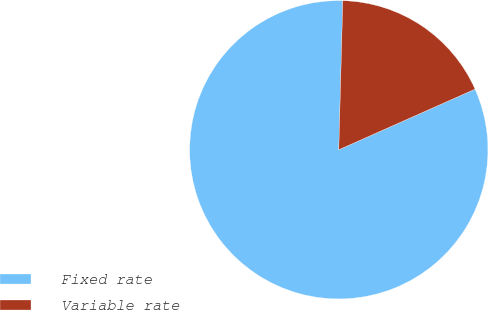Convert chart. <chart><loc_0><loc_0><loc_500><loc_500><pie_chart><fcel>Fixed rate<fcel>Variable rate<nl><fcel>82.09%<fcel>17.91%<nl></chart> 